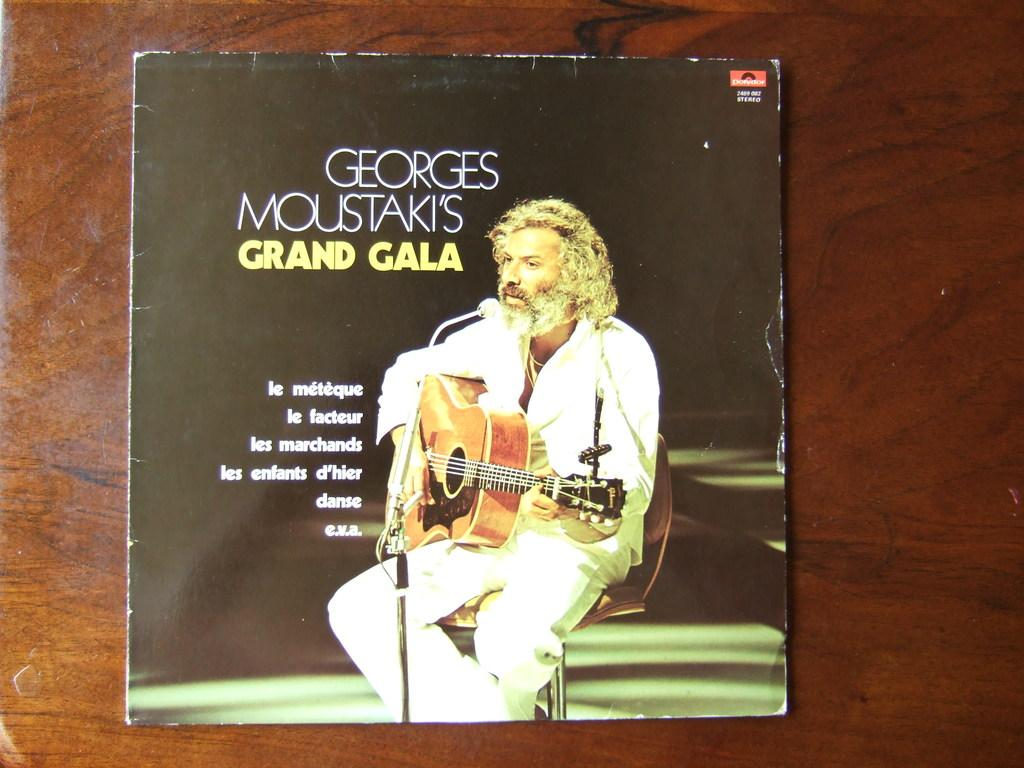What object is visible in the image that is related to reading or learning? There is a book in the image. Where is the book located in the image? The book is being kept on a surface. What activity is the person in the image engaged in? The person in the image is playing a musical instrument. Can you describe the position of the person in the image? The person is sitting in a chair. What type of slope can be seen in the image? There is no slope present in the image. What is the profit generated by the person playing the musical instrument in the image? The image does not provide any information about profit or financial gain. 